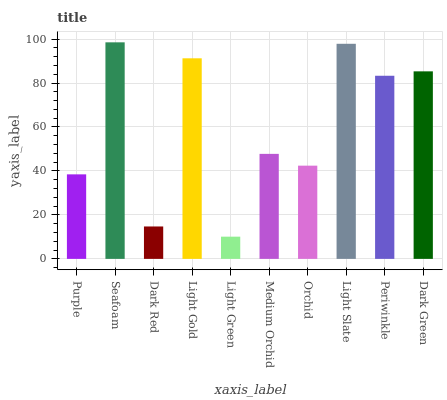Is Light Green the minimum?
Answer yes or no. Yes. Is Seafoam the maximum?
Answer yes or no. Yes. Is Dark Red the minimum?
Answer yes or no. No. Is Dark Red the maximum?
Answer yes or no. No. Is Seafoam greater than Dark Red?
Answer yes or no. Yes. Is Dark Red less than Seafoam?
Answer yes or no. Yes. Is Dark Red greater than Seafoam?
Answer yes or no. No. Is Seafoam less than Dark Red?
Answer yes or no. No. Is Periwinkle the high median?
Answer yes or no. Yes. Is Medium Orchid the low median?
Answer yes or no. Yes. Is Medium Orchid the high median?
Answer yes or no. No. Is Orchid the low median?
Answer yes or no. No. 